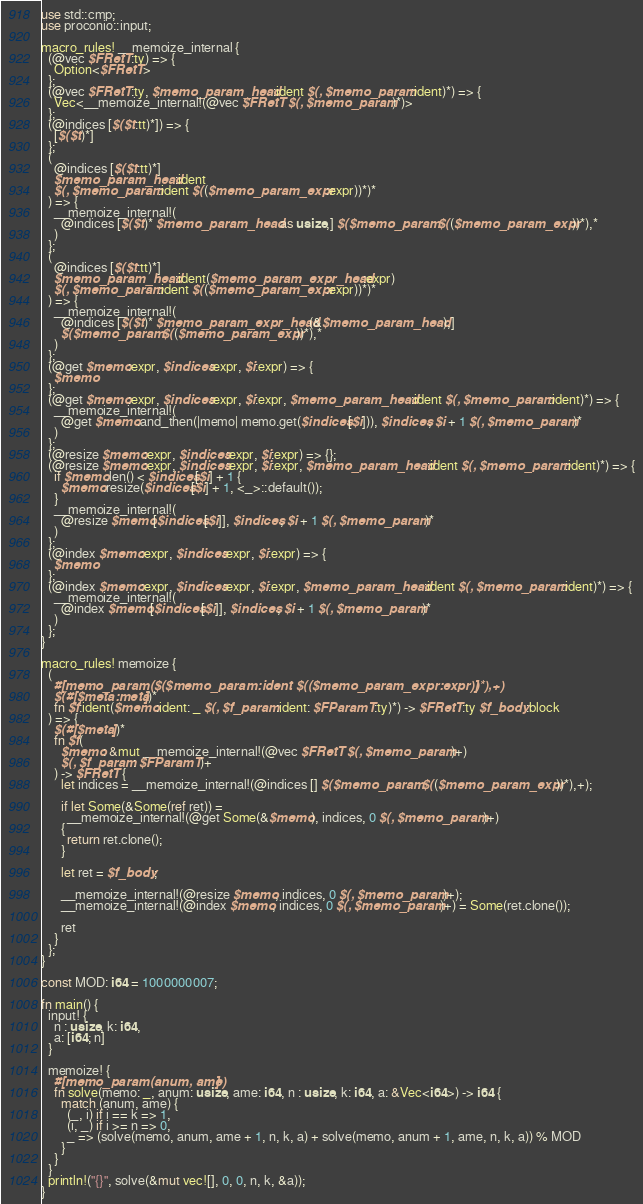<code> <loc_0><loc_0><loc_500><loc_500><_Rust_>use std::cmp;
use proconio::input;

macro_rules! __memoize_internal {
  (@vec $FRetT:ty) => {
    Option<$FRetT>
  };
  (@vec $FRetT:ty, $memo_param_head:ident $(, $memo_param:ident)*) => {
    Vec<__memoize_internal!(@vec $FRetT $(, $memo_param)*)>
  };
  (@indices [$($t:tt)*]) => {
    [$($t)*]
  };
  (
    @indices [$($t:tt)*]
    $memo_param_head:ident
    $(, $memo_param:ident $(($memo_param_expr:expr))*)*
  ) => {
    __memoize_internal!(
      @indices [$($t)* $memo_param_head as usize,] $($memo_param $(($memo_param_expr))*),*
    )
  };
  (
    @indices [$($t:tt)*]
    $memo_param_head:ident($memo_param_expr_head:expr)
    $(, $memo_param:ident $(($memo_param_expr:expr))*)*
  ) => {
    __memoize_internal!(
      @indices [$($t)* $memo_param_expr_head(&$memo_param_head),]
      $($memo_param $(($memo_param_expr))*),*
    )
  };
  (@get $memo:expr, $indices:expr, $i:expr) => {
    $memo
  };
  (@get $memo:expr, $indices:expr, $i:expr, $memo_param_head:ident $(, $memo_param:ident)*) => {
    __memoize_internal!(
      @get $memo.and_then(|memo| memo.get($indices[$i])), $indices, $i + 1 $(, $memo_param)*
    )
  };
  (@resize $memo:expr, $indices:expr, $i:expr) => {};
  (@resize $memo:expr, $indices:expr, $i:expr, $memo_param_head:ident $(, $memo_param:ident)*) => {
    if $memo.len() < $indices[$i] + 1 {
      $memo.resize($indices[$i] + 1, <_>::default());
    }
    __memoize_internal!(
      @resize $memo[$indices[$i]], $indices, $i + 1 $(, $memo_param)*
    )
  };
  (@index $memo:expr, $indices:expr, $i:expr) => {
    $memo
  };
  (@index $memo:expr, $indices:expr, $i:expr, $memo_param_head:ident $(, $memo_param:ident)*) => {
    __memoize_internal!(
      @index $memo[$indices[$i]], $indices, $i + 1 $(, $memo_param)*
    )
  };
}

macro_rules! memoize {
  (
    #[memo_param($($memo_param:ident $(($memo_param_expr:expr))*),+)]
    $(#[$meta:meta])*
    fn $f:ident($memo:ident: _ $(, $f_param:ident: $FParamT:ty)*) -> $FRetT:ty $f_body:block
  ) => {
    $(#[$meta])*
    fn $f(
      $memo: &mut __memoize_internal!(@vec $FRetT $(, $memo_param)+)
      $(, $f_param: $FParamT)+
    ) -> $FRetT {
      let indices = __memoize_internal!(@indices [] $($memo_param $(($memo_param_expr))*),+);

      if let Some(&Some(ref ret)) =
        __memoize_internal!(@get Some(&$memo), indices, 0 $(, $memo_param)+)
      {
        return ret.clone();
      }

      let ret = $f_body;

      __memoize_internal!(@resize $memo, indices, 0 $(, $memo_param)+);
      __memoize_internal!(@index $memo, indices, 0 $(, $memo_param)+) = Some(ret.clone());

      ret
    }
  };
}

const MOD: i64 = 1000000007;

fn main() {
  input! {
    n : usize, k: i64,
    a: [i64; n]
  }
  
  memoize! {
    #[memo_param(anum, ame)]
    fn solve(memo: _, anum: usize, ame: i64, n : usize, k: i64, a: &Vec<i64>) -> i64 {
      match (anum, ame) {
        (_, i) if i == k => 1,
        (i, _) if i >= n => 0,
        _ => (solve(memo, anum, ame + 1, n, k, a) + solve(memo, anum + 1, ame, n, k, a)) % MOD
      }
    }
  }
  println!("{}", solve(&mut vec![], 0, 0, n, k, &a));
}

</code> 